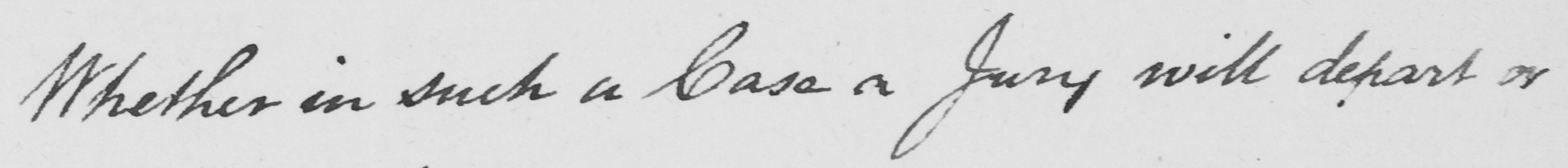Please transcribe the handwritten text in this image. Whether in such a Case a Jury will depart or 